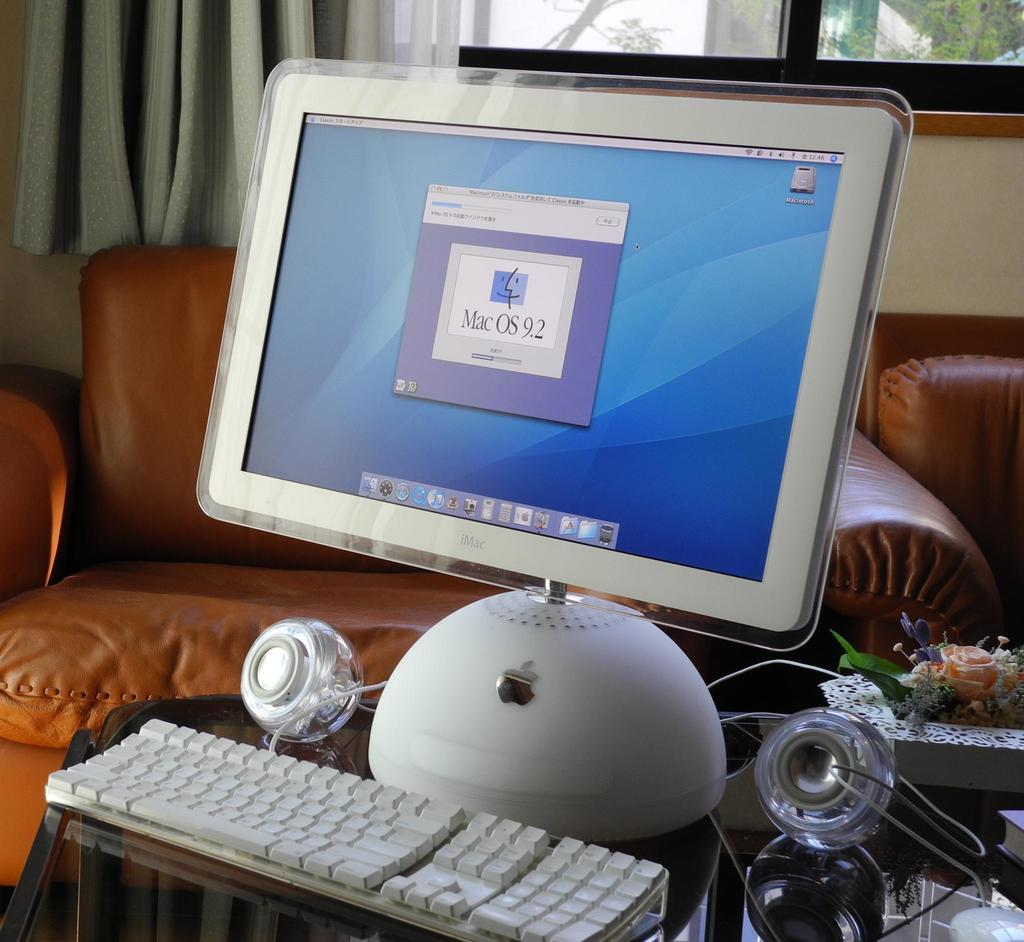What type of electronic device is visible in the image? There is an Apple monitor in the image. What is used for typing on the Apple monitor? There is a keyboard in the image. How many speakers are present in the image? There are two speakers in the image. What type of furniture can be seen in the background of the image? There are two brown sofas in the background of the image. What type of window treatment is present in the image? There is a curtain in the background of the image. What is located beside the curtain in the background of the image? There is a window beside the curtain in the background of the image. What type of range can be seen in the image? There is no range present in the image. What is being smashed in the image? There is no smashing activity depicted in the image. 